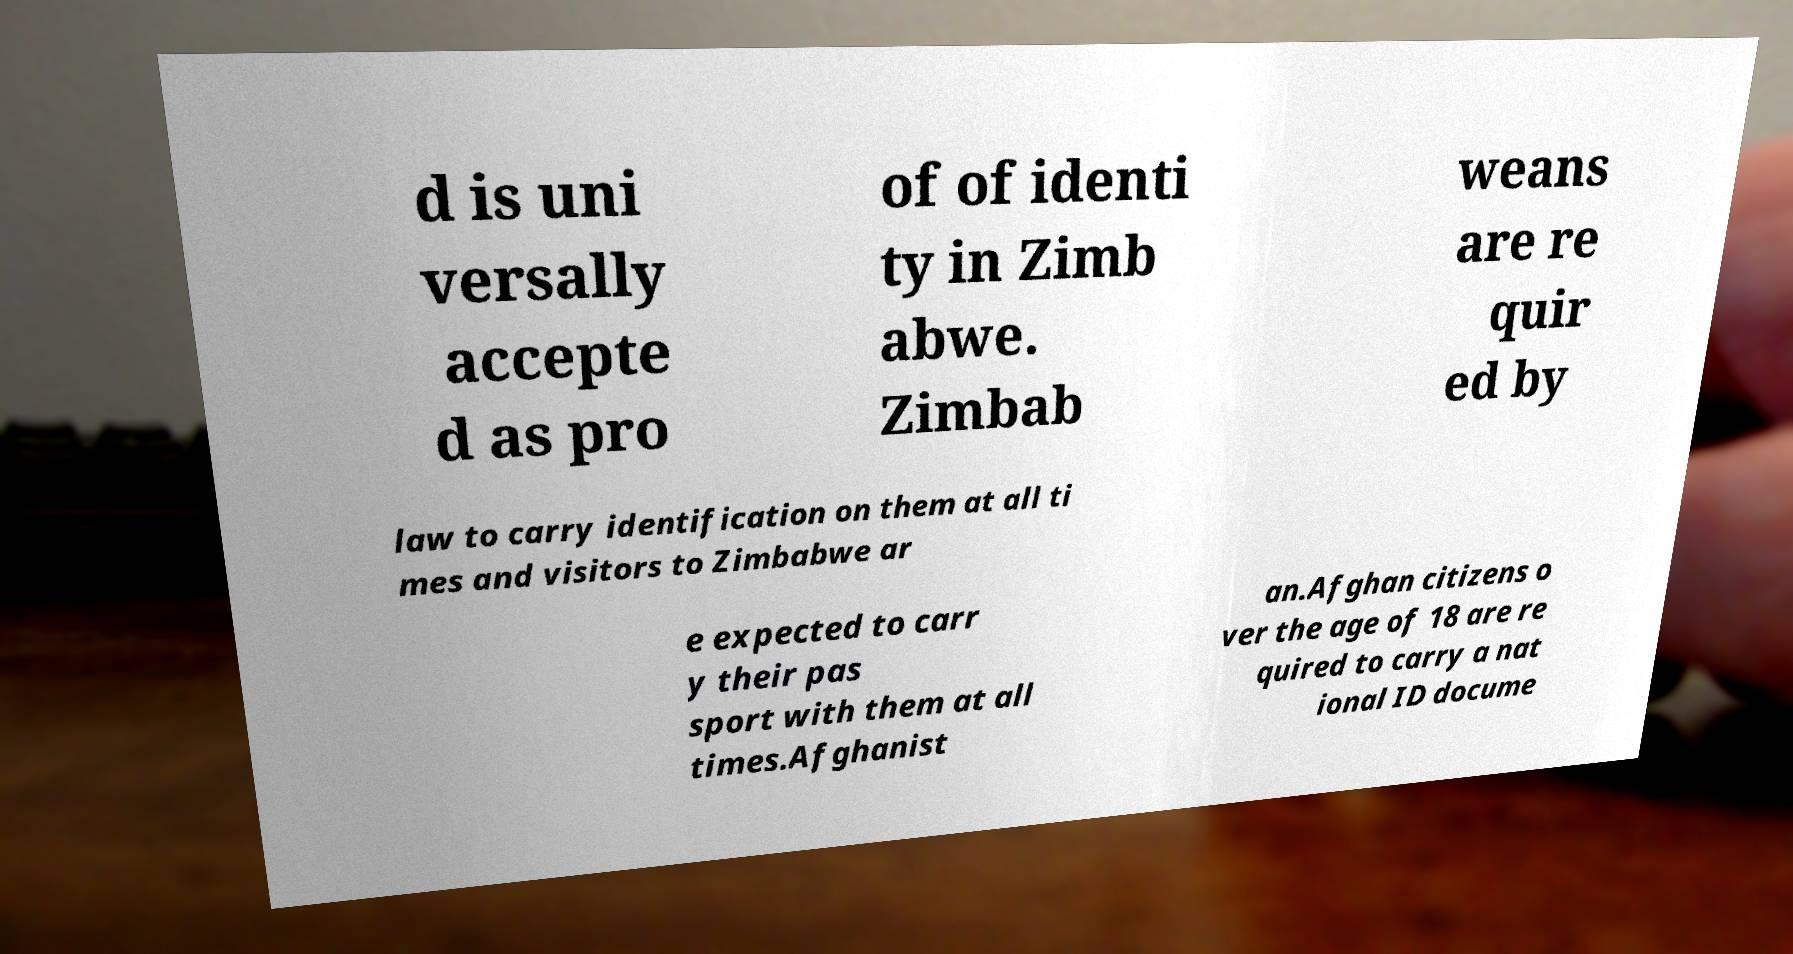For documentation purposes, I need the text within this image transcribed. Could you provide that? d is uni versally accepte d as pro of of identi ty in Zimb abwe. Zimbab weans are re quir ed by law to carry identification on them at all ti mes and visitors to Zimbabwe ar e expected to carr y their pas sport with them at all times.Afghanist an.Afghan citizens o ver the age of 18 are re quired to carry a nat ional ID docume 